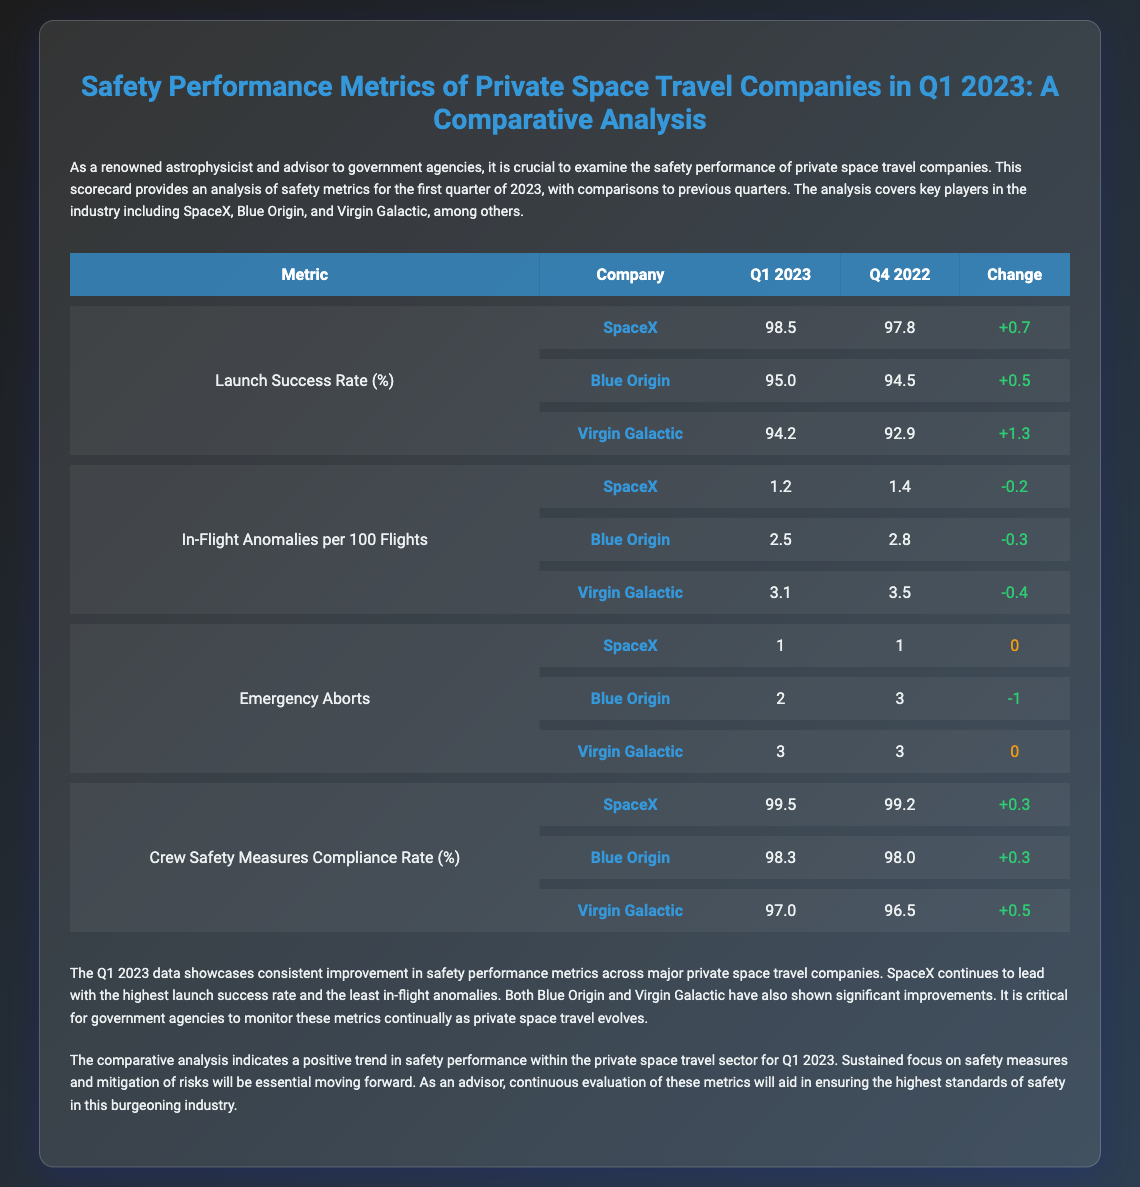What is the launch success rate for SpaceX in Q1 2023? The launch success rate for SpaceX in Q1 2023 is explicitly stated in the table.
Answer: 98.5 How many in-flight anomalies per 100 flights did Blue Origin report in Q1 2023? The data shows the number of in-flight anomalies per 100 flights for Blue Origin for Q1 2023.
Answer: 2.5 What change in crew safety measures compliance rate did Virgin Galactic experience from Q4 2022 to Q1 2023? The change in compliance rate for Virgin Galactic is calculated based on the values provided for both quarters.
Answer: +0.5 Which company had the highest launch success rate in Q1 2023? The document lists the launch success rates for each company, identifying the highest rate.
Answer: SpaceX How many emergency aborts did Blue Origin have in Q4 2022? The table specifically lists the number of emergency aborts for Blue Origin in Q4 2022.
Answer: 3 What was the trend in in-flight anomalies for SpaceX from Q4 2022 to Q1 2023? The trends are detailed in the document, indicating changes in the in-flight anomalies metric over the two quarters.
Answer: Decrease What was the overall summary of safety performance in Q1 2023? The summary section provides an overall assessment of safety performance metrics in Q1 2023.
Answer: Consistent improvement How many total companies were evaluated in the scorecard? The introduction specifies the key players in the scorecard analysis, which indicates the number of evaluated companies.
Answer: Three What is the emergency abort count for Virgin Galactic in Q1 2023? The emergency abort count for Virgin Galactic in Q1 2023 is provided in the table.
Answer: 3 